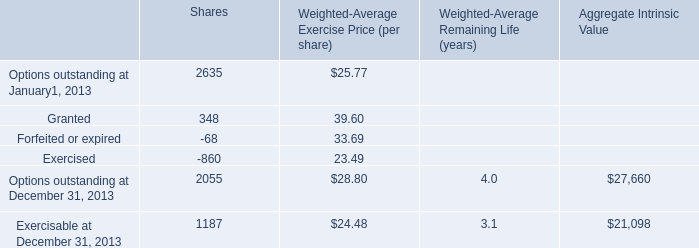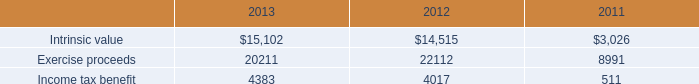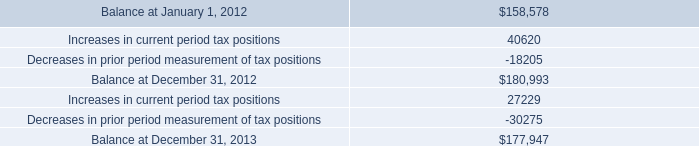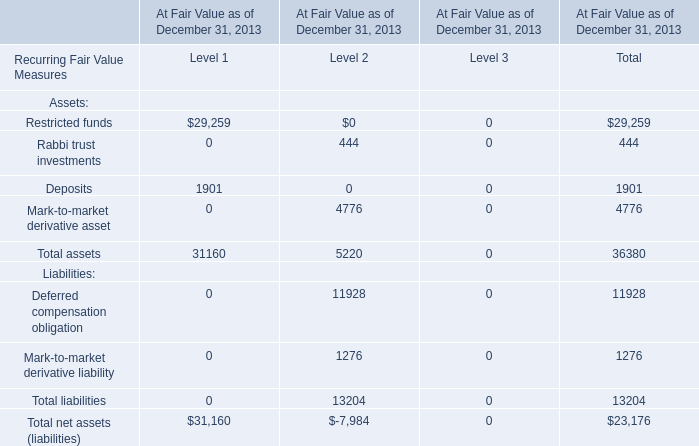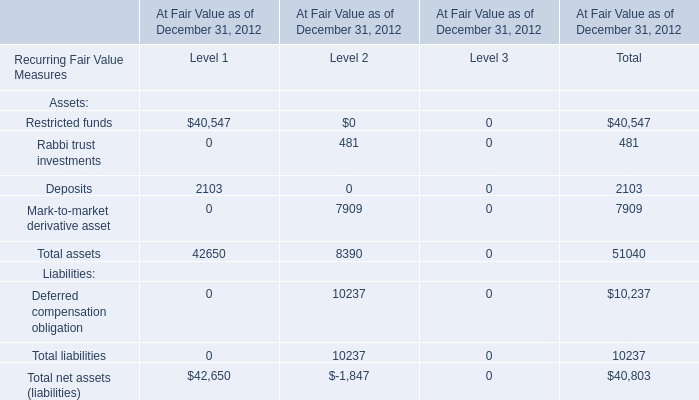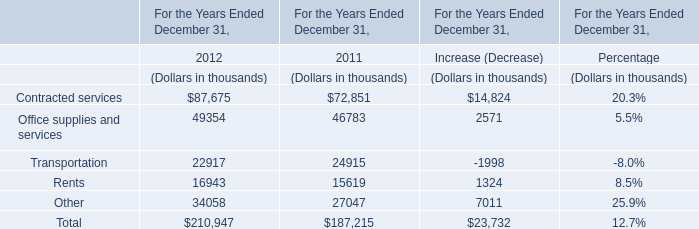as of december 31.2013 what was the ratio of the interest and penalty as a percent of the total unrecognized tax benefits 
Computations: (242 / (242 + 177947))
Answer: 0.00136. 